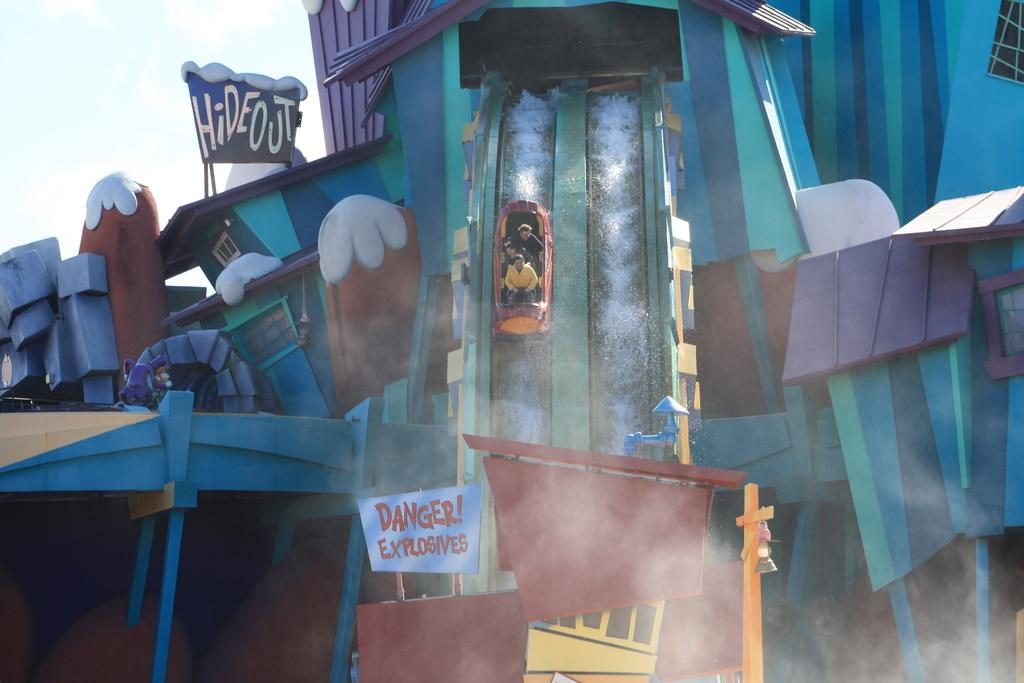What is the main feature in the image? There is a water slide in the image. Can you describe the people in the image? There are three persons sitting in a boat. What can be seen in the background of the image? The sky is visible in the background of the image, and it appears to be white in color. How many mice are comfortably sitting in the boat with the three persons? There are no mice present in the image, so it is not possible to determine how many would be comfortably sitting in the boat with the three persons. 